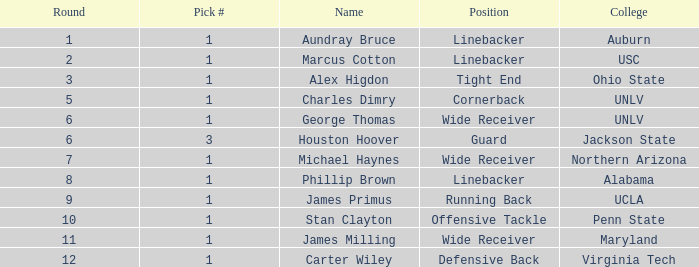In what Round with an Overall greater than 306 was the pick from the College of Virginia Tech? 0.0. 